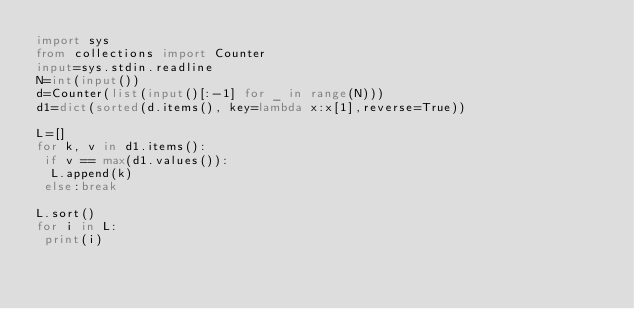<code> <loc_0><loc_0><loc_500><loc_500><_Python_>import sys
from collections import Counter
input=sys.stdin.readline
N=int(input())
d=Counter(list(input()[:-1] for _ in range(N)))
d1=dict(sorted(d.items(), key=lambda x:x[1],reverse=True))

L=[]
for k, v in d1.items():
 if v == max(d1.values()):
  L.append(k)
 else:break

L.sort()
for i in L:
 print(i)</code> 